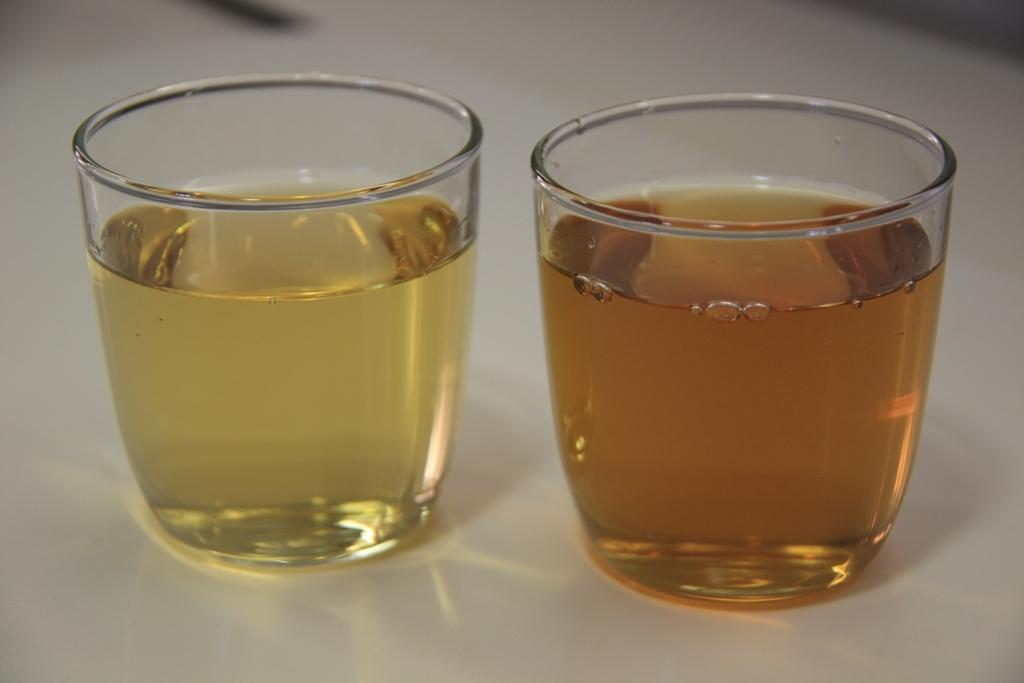What objects are in the image that are used for drinking? There are glasses in the image that are used for drinking. What is inside the glasses? The glasses contain beverages. Where are the glasses located in the image? The glasses are placed on a table. What type of hair is visible on the glasses in the image? There is no hair visible on the glasses in the image. 